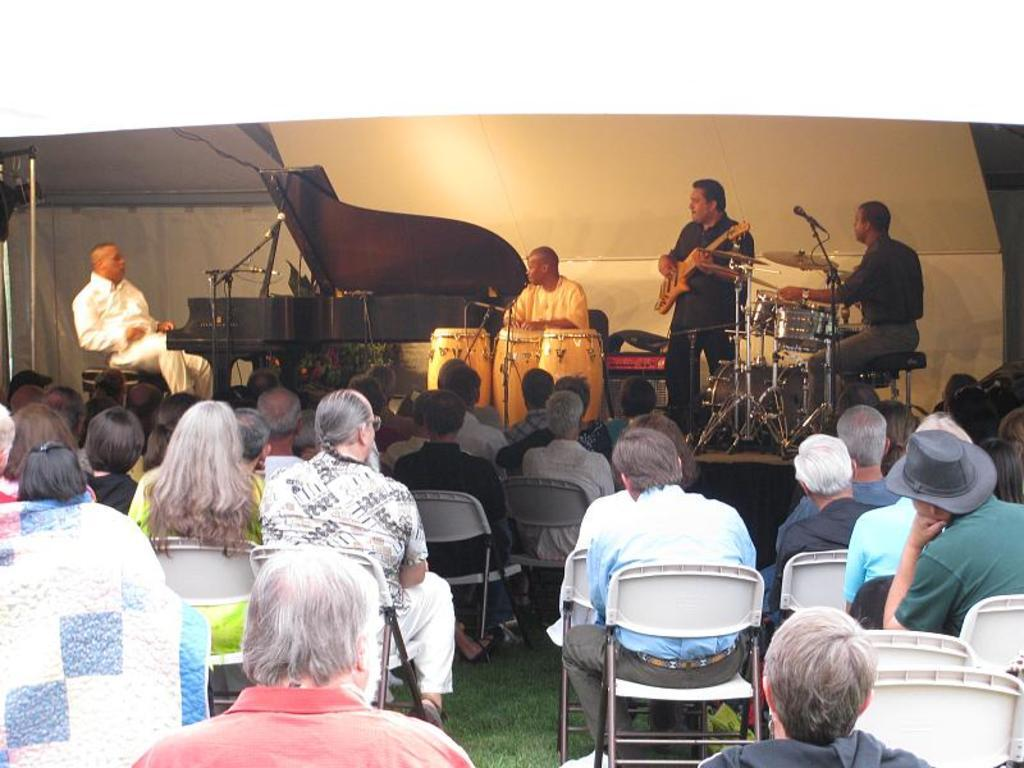What are the people in the image doing? There is a group of people sitting on chairs in the image, and three persons are playing musical instruments. How many people are playing musical instruments? Three persons are playing musical instruments in the image. What type of wheel can be seen in the image? There is no wheel present in the image. How does the group of people stop playing their instruments in the image? The image does not show the group of people stopping their musical performance, so it cannot be determined from the image. 